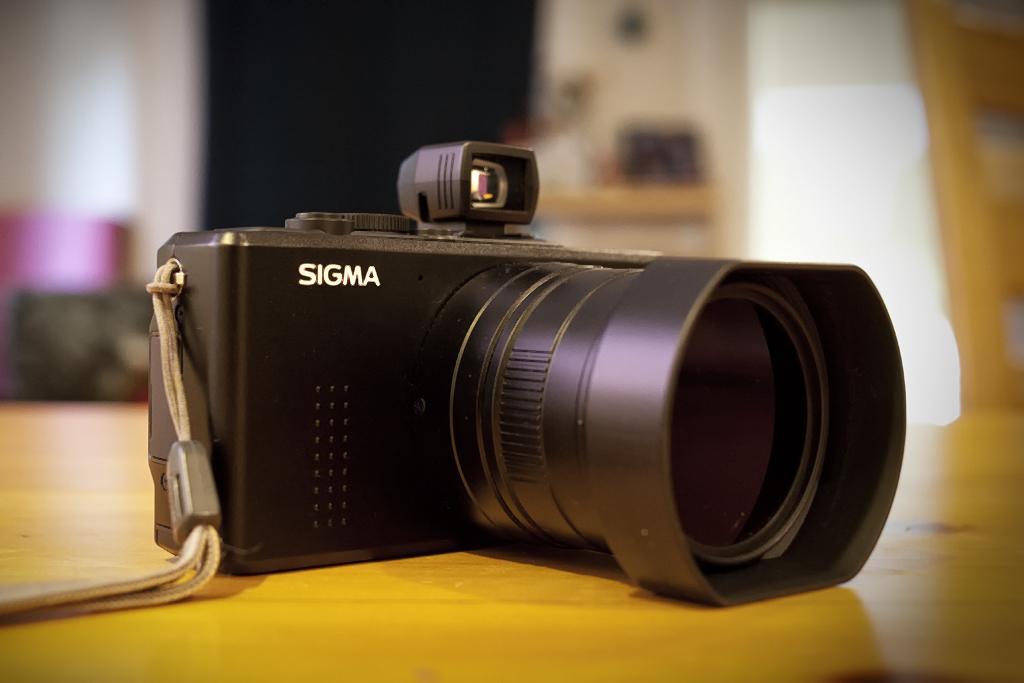How would you summarize this image in a sentence or two? In this image we can see one camera on the table, some objects in the background and the background is blurred. 